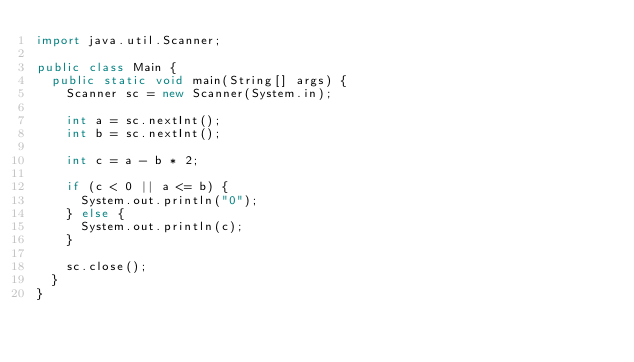<code> <loc_0><loc_0><loc_500><loc_500><_Java_>import java.util.Scanner;

public class Main {
	public static void main(String[] args) {
		Scanner sc = new Scanner(System.in);

		int a = sc.nextInt();
		int b = sc.nextInt();

		int c = a - b * 2;

		if (c < 0 || a <= b) {
			System.out.println("0");
		} else {
			System.out.println(c);
		}

		sc.close();
	}
}</code> 